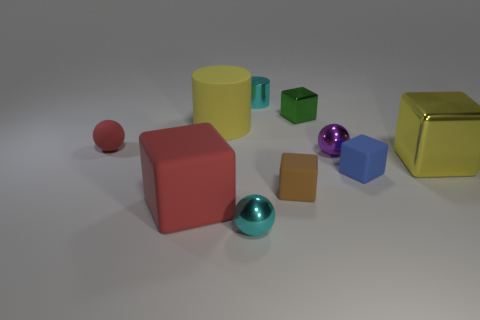Subtract all tiny rubber cubes. How many cubes are left? 3 Subtract all cylinders. How many objects are left? 8 Subtract all red balls. How many balls are left? 2 Subtract 4 blocks. How many blocks are left? 1 Subtract all blue blocks. Subtract all yellow cylinders. How many blocks are left? 4 Subtract all gray cylinders. How many cyan balls are left? 1 Subtract all large blue metal cylinders. Subtract all small shiny cylinders. How many objects are left? 9 Add 8 brown things. How many brown things are left? 9 Add 4 matte objects. How many matte objects exist? 9 Subtract 0 gray cylinders. How many objects are left? 10 